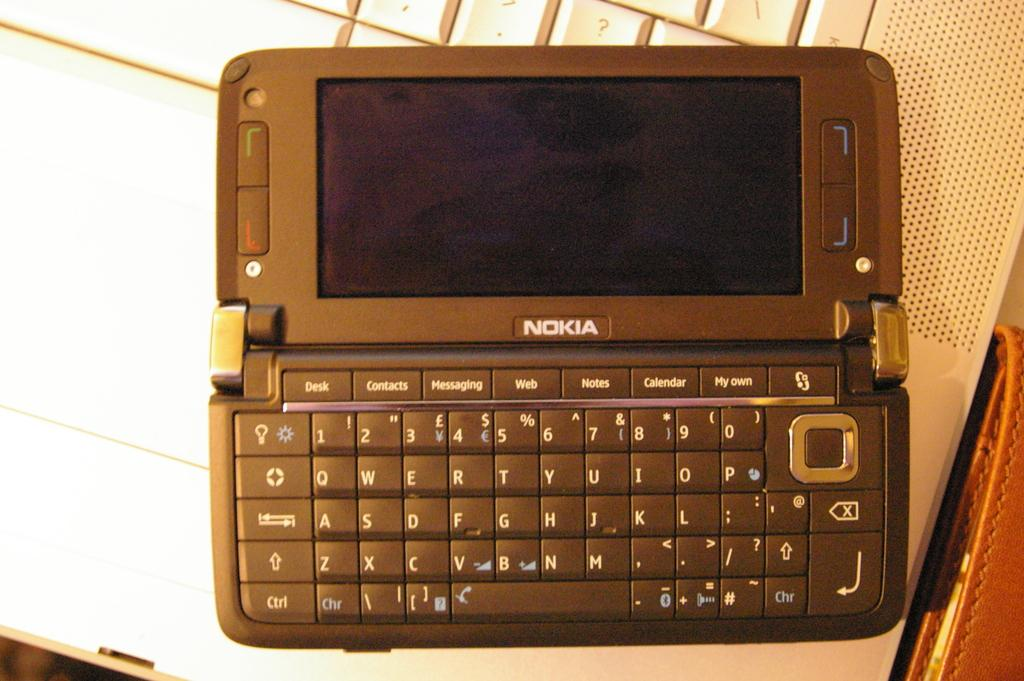Provide a one-sentence caption for the provided image. Nokia is the brand shown on this personal organizer. 